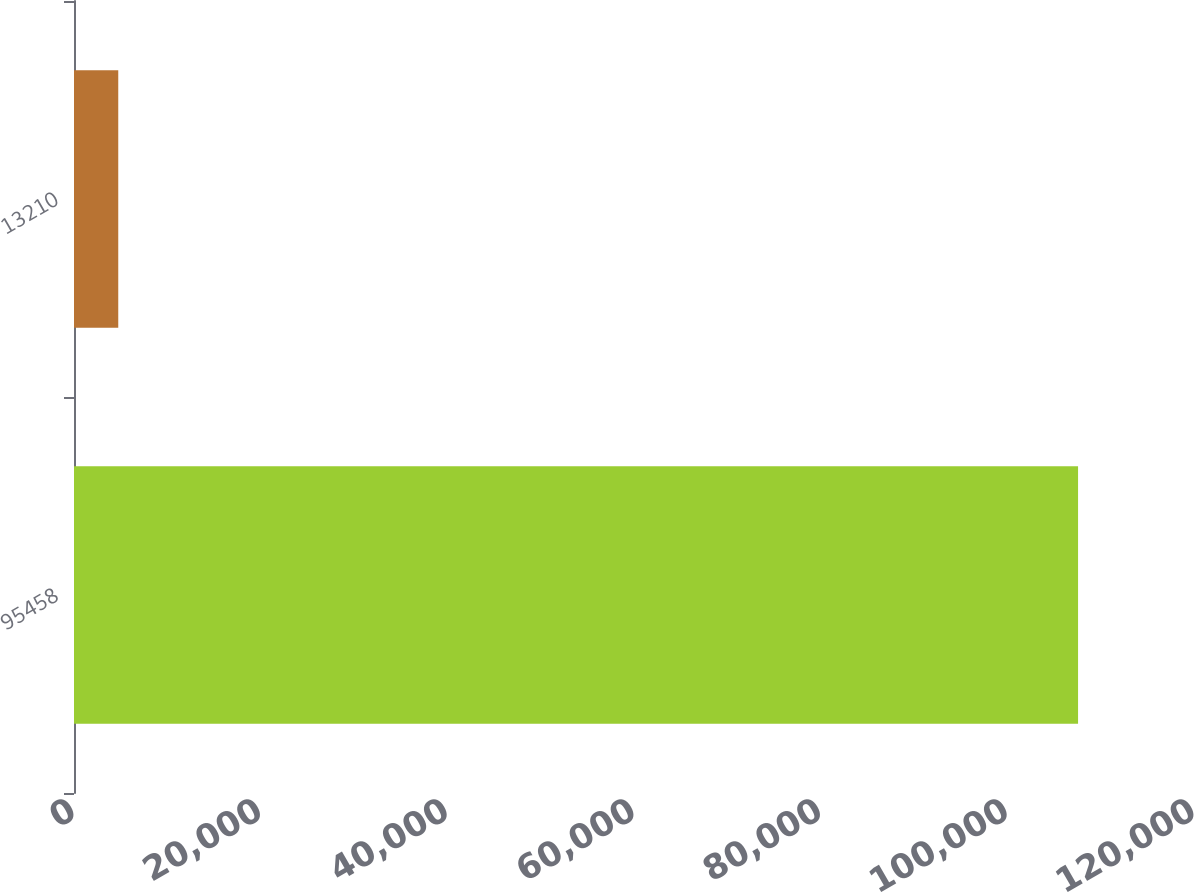Convert chart to OTSL. <chart><loc_0><loc_0><loc_500><loc_500><bar_chart><fcel>95458<fcel>13210<nl><fcel>107578<fcel>4742<nl></chart> 